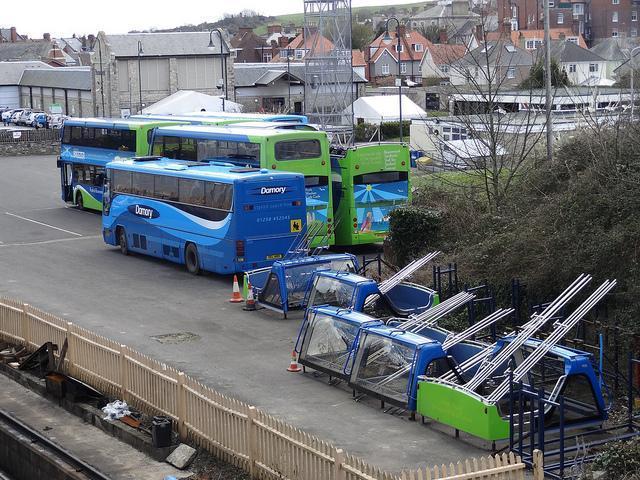How many buses are in the picture?
Give a very brief answer. 4. How many books are there to the right of the clock?
Give a very brief answer. 0. 